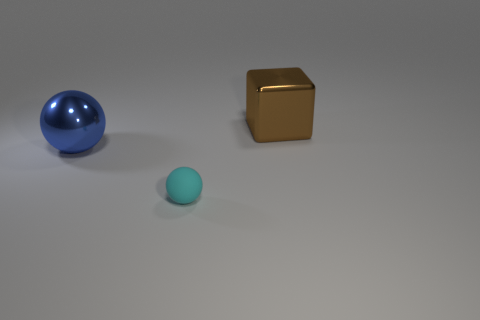What could be the purpose of this arrangement? This arrangement could serve several purposes. It might be a simple artistic composition designed to study shapes, colors, and shadows. Alternatively, it could be a setup for a photography project, a physics simulation of objects in space, or even a minimalist still life. 